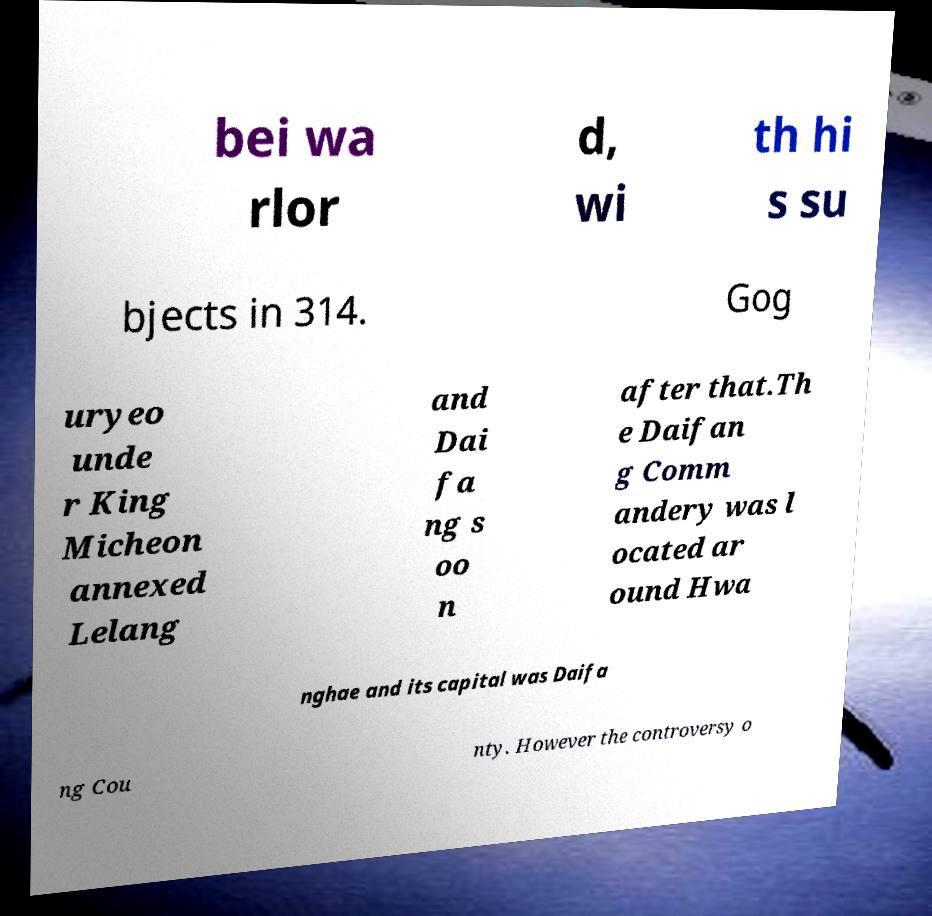What messages or text are displayed in this image? I need them in a readable, typed format. bei wa rlor d, wi th hi s su bjects in 314. Gog uryeo unde r King Micheon annexed Lelang and Dai fa ng s oo n after that.Th e Daifan g Comm andery was l ocated ar ound Hwa nghae and its capital was Daifa ng Cou nty. However the controversy o 